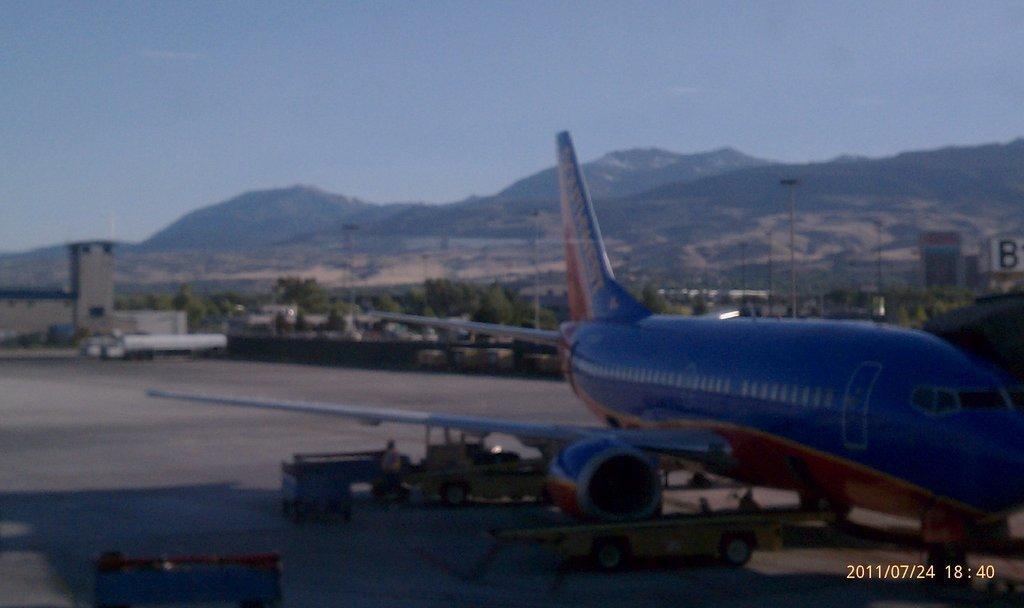How would you summarize this image in a sentence or two? Here we can see an aeroplane and vehicles and few persons on the road. In the background there are trees,poles,vehicle,buildings,mountains and sky. 